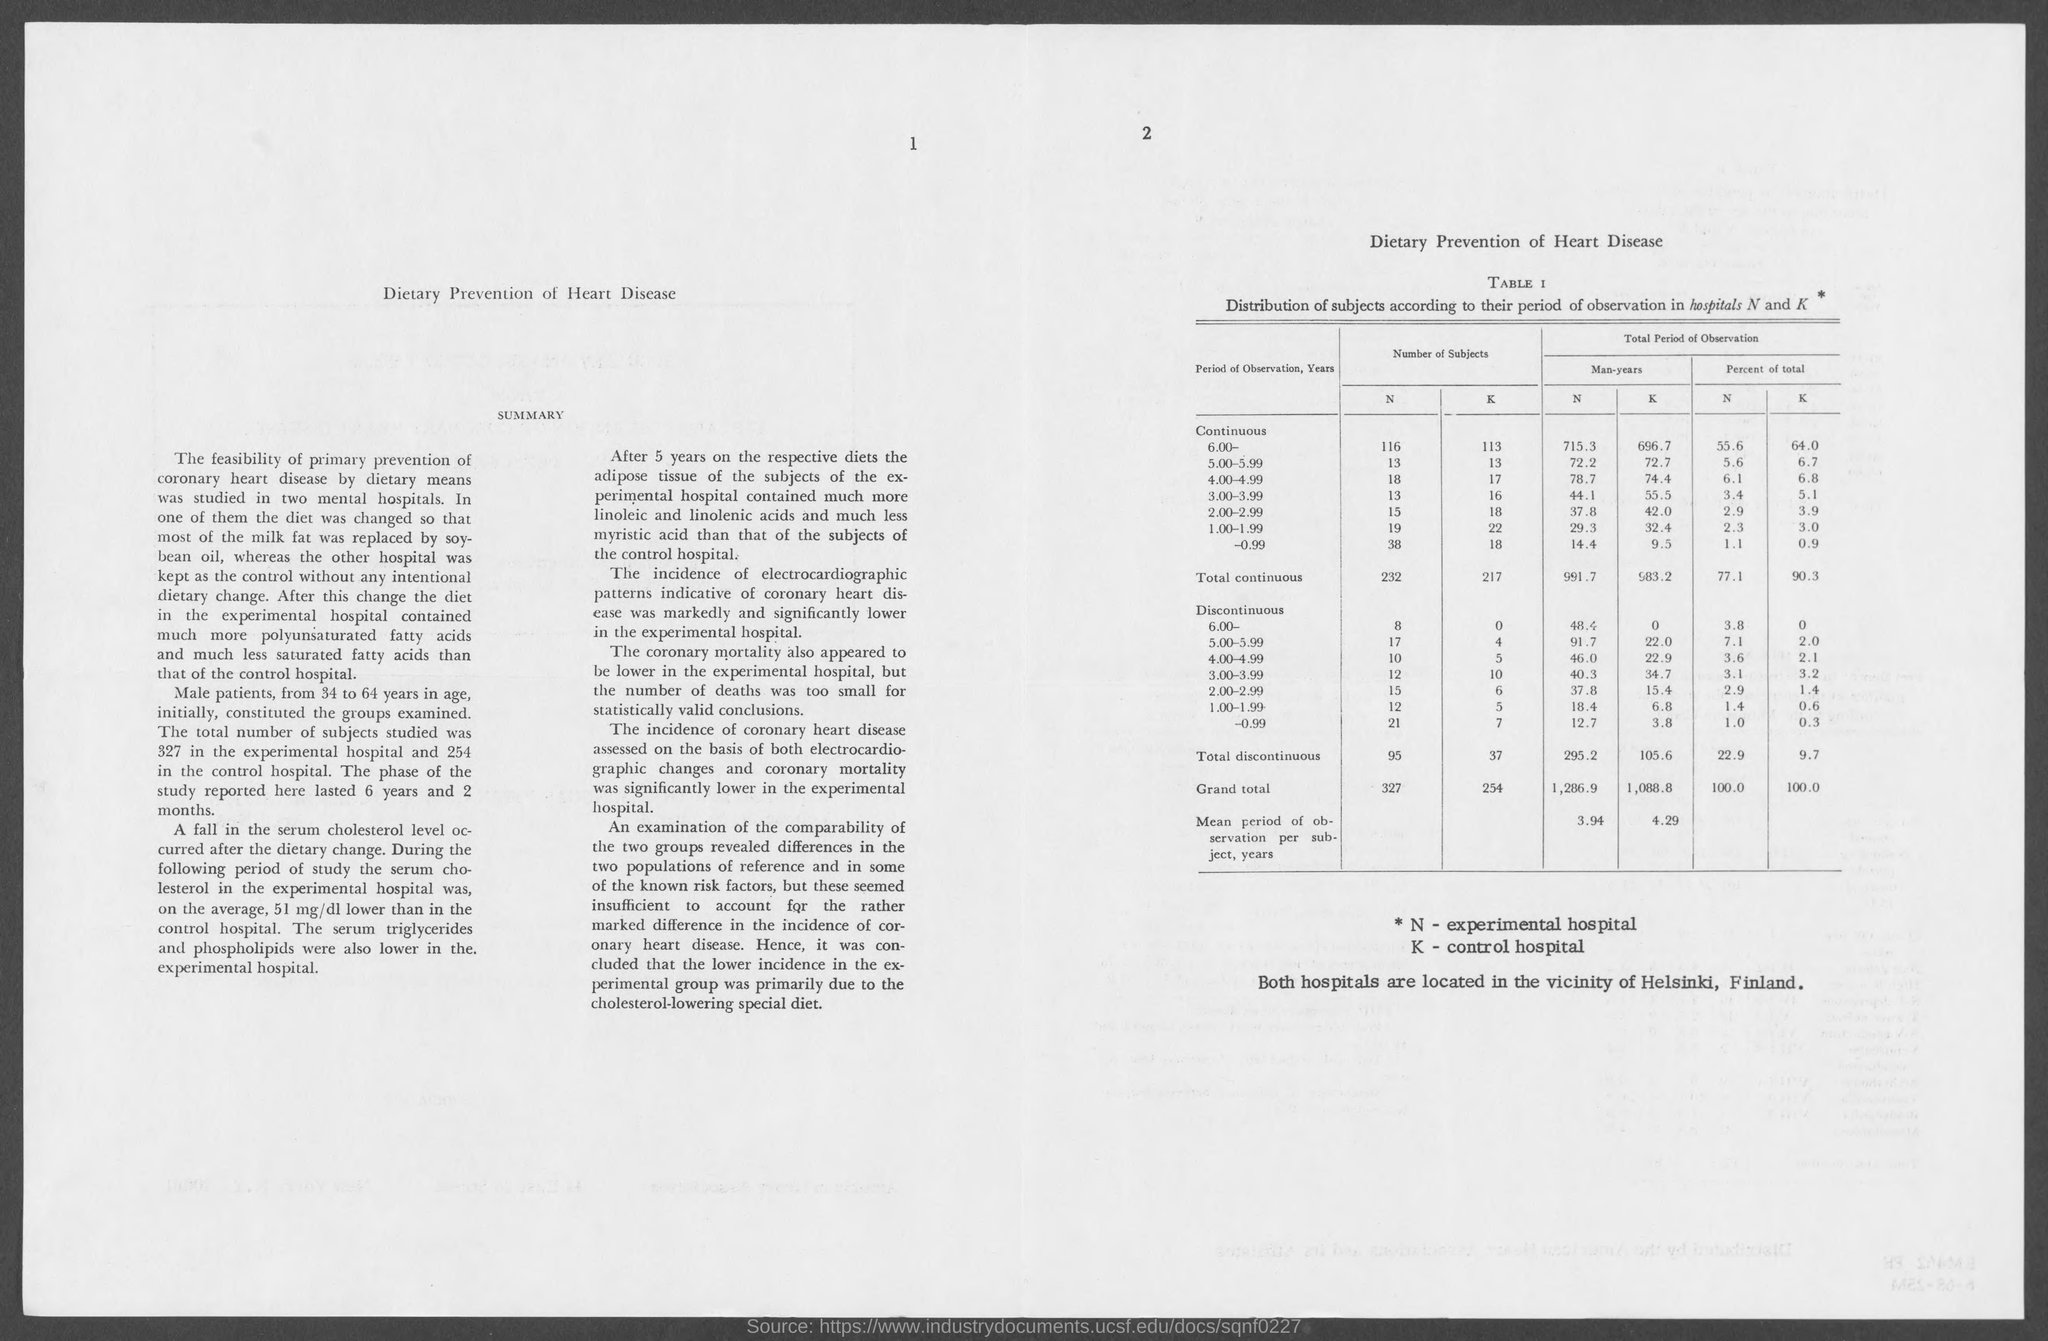Outline some significant characteristics in this image. Both hospitals are located in the vicinity of Helsinki, Finland. The type of hospitals represented by the letter 'K' is unknown, but it is likely a control hospital. The title of the document is "Dietary Prevention of Heart Disease. The type of hospitals represented by 'N' is experimental hospitals. The title of Table 1 is "Distribution of subjects according to their period of observation in hospitals N and K. 